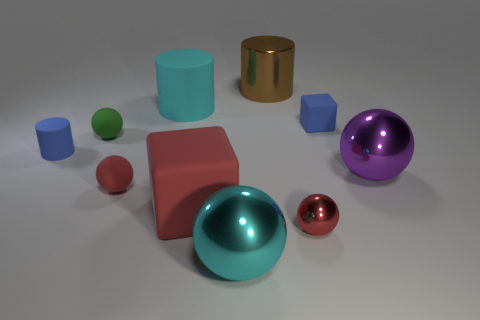Is there a tiny green thing that has the same shape as the brown metallic object?
Ensure brevity in your answer.  No. What is the shape of the big object that is in front of the purple thing and behind the cyan metal ball?
Provide a short and direct response. Cube. How many small green things have the same material as the large cyan sphere?
Your answer should be very brief. 0. Are there fewer things to the right of the blue cube than yellow things?
Your answer should be compact. No. There is a big object that is to the right of the blue cube; is there a tiny green thing that is in front of it?
Give a very brief answer. No. Is there any other thing that has the same shape as the small green object?
Your response must be concise. Yes. Is the blue rubber cube the same size as the green ball?
Give a very brief answer. Yes. There is a cyan thing behind the matte cube behind the blue object on the left side of the blue block; what is it made of?
Offer a terse response. Rubber. Is the number of blue rubber cubes that are on the left side of the tiny cylinder the same as the number of tiny red cylinders?
Ensure brevity in your answer.  Yes. Is there any other thing that is the same size as the green rubber ball?
Your answer should be very brief. Yes. 